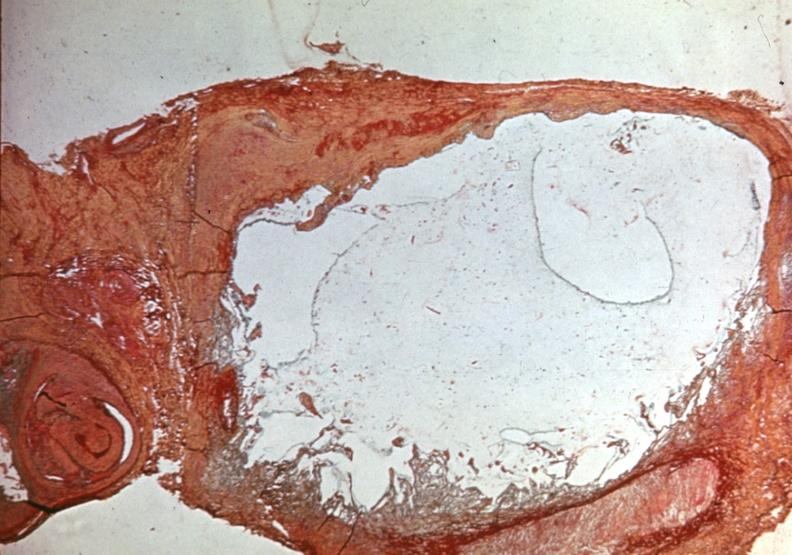does this image show popliteal cyst myxoid?
Answer the question using a single word or phrase. Yes 